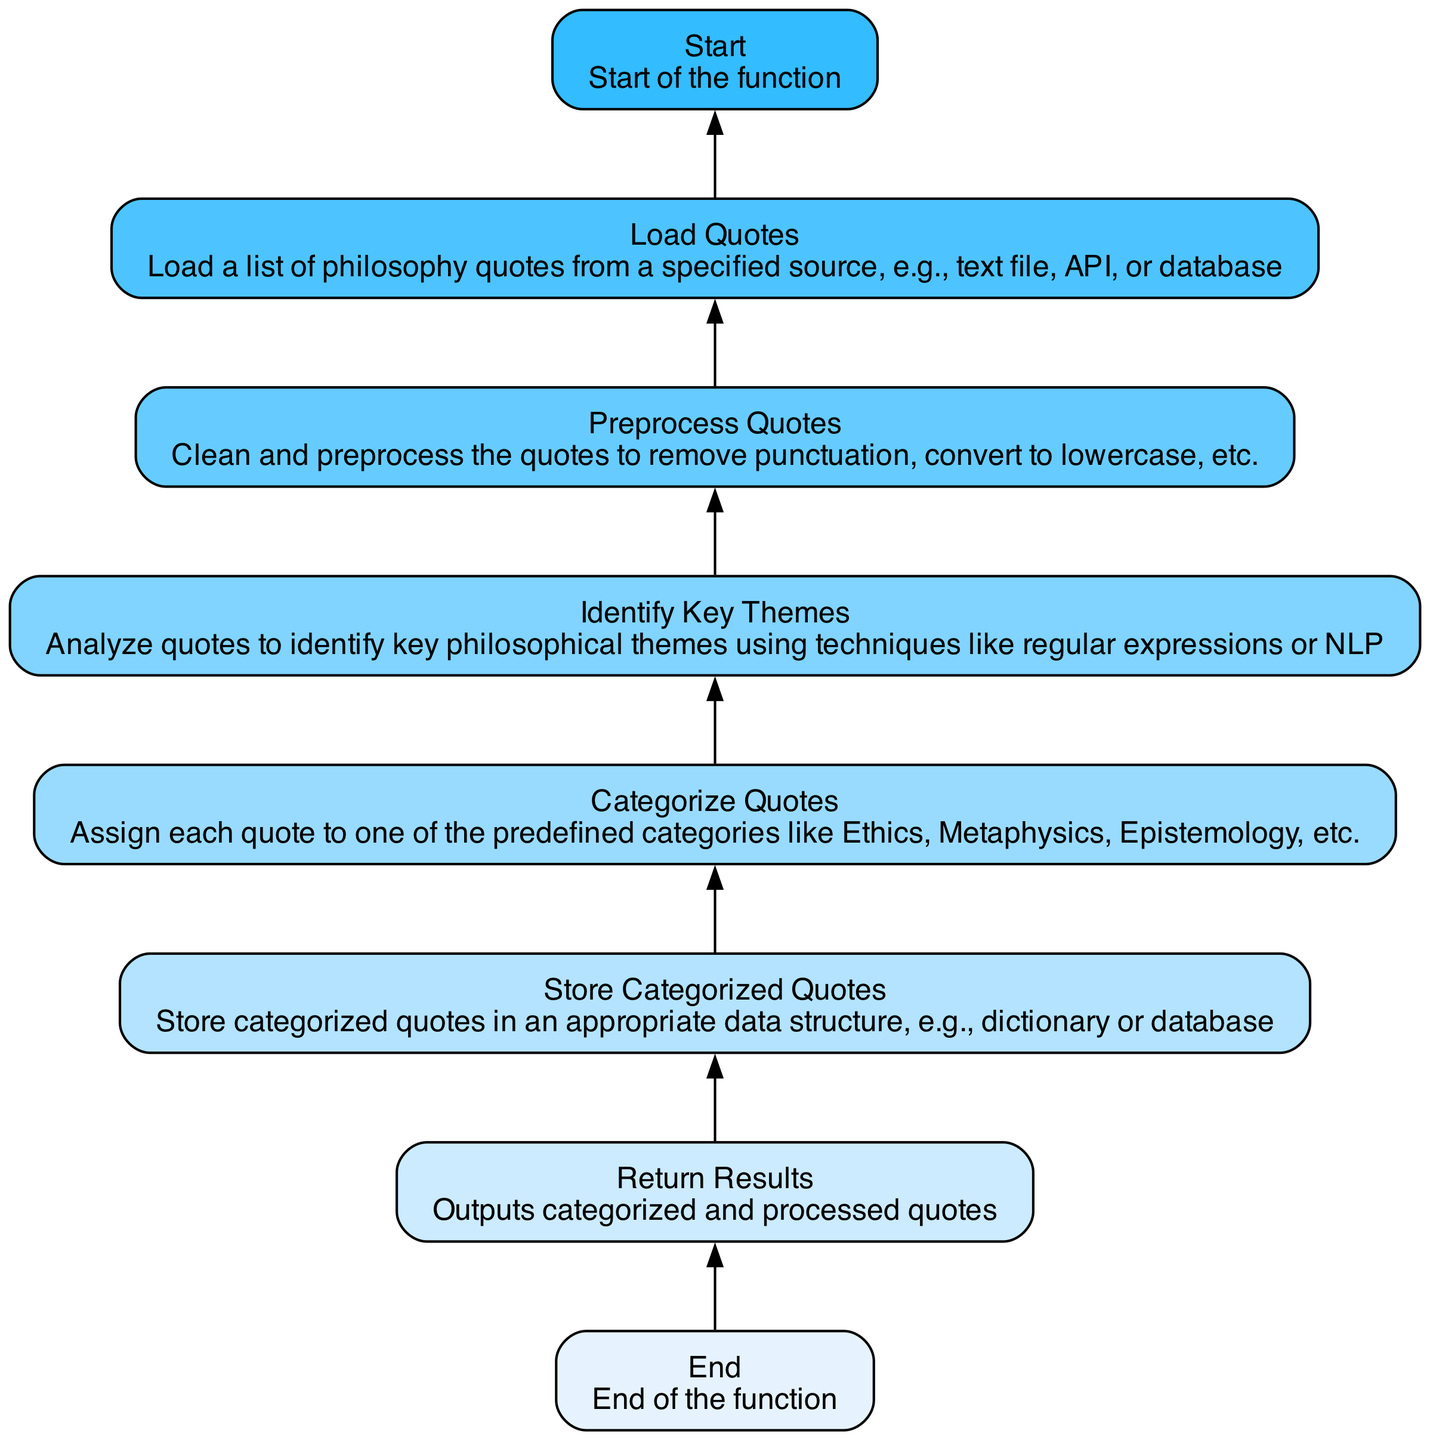What is the first step in the function? The first step in the function is represented by the node named "Start". This node initiates the process of processing philosophy quotes, as seen at the beginning of the flowchart.
Answer: Start How many nodes are there in total? Counting all the listed elements in the diagram, we find there are 8 nodes: Start, Load Quotes, Preprocess Quotes, Identify Key Themes, Categorize Quotes, Store Categorized Quotes, Return Results, and End.
Answer: 8 What comes immediately after 'Load Quotes'? After 'Load Quotes', the next step is 'Preprocess Quotes'. This is evident because the arrows linking the nodes direct the flow from 'Load Quotes' to 'Preprocess Quotes'.
Answer: Preprocess Quotes Which node represents the conclusion of the function? The conclusion of the function is represented by the 'End' node. This node indicates the termination of the process after all other steps are complete, marking the completion of the function's execution.
Answer: End What is the purpose of the 'Categorize Quotes' step? The 'Categorize Quotes' step serves to assign each quote to predefined categories such as Ethics, Metaphysics, and Epistemology. This is critical because it organizes the quotes into meaningful philosophical themes based on content.
Answer: Assign categories Which two nodes are connected directly without any nodes in between? The 'Store Categorized Quotes' node and the 'Return Results' node are directly connected without any intermediate nodes. This indicates that once quotes are stored, the next action is to return the processed results immediately.
Answer: Store Categorized Quotes, Return Results What is the order of processing quotes from the beginning to the end? The order follows these steps: Start, Load Quotes, Preprocess Quotes, Identify Key Themes, Categorize Quotes, Store Categorized Quotes, Return Results, and finally End. This sequence shows the overall flow of quote processing from initiation to conclusion.
Answer: Start, Load Quotes, Preprocess Quotes, Identify Key Themes, Categorize Quotes, Store Categorized Quotes, Return Results, End How do the 'Identify Key Themes' and 'Categorize Quotes' nodes relate to each other? The 'Identify Key Themes' node feeds into the 'Categorize Quotes' node, indicating that the analysis of key themes is a precondition for properly categorizing the quotes into their respective philosophical areas. Thus, the output of one step is critical for the input of the next.
Answer: Identify themes for categorization 